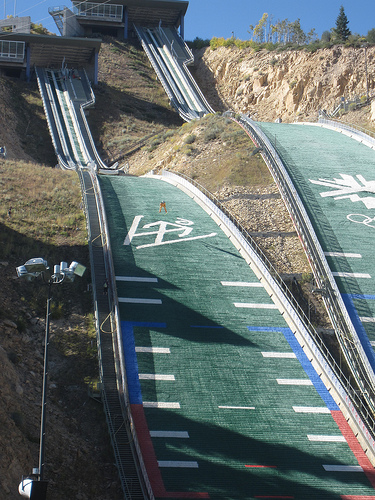<image>
Can you confirm if the road is behind the hill? No. The road is not behind the hill. From this viewpoint, the road appears to be positioned elsewhere in the scene. 